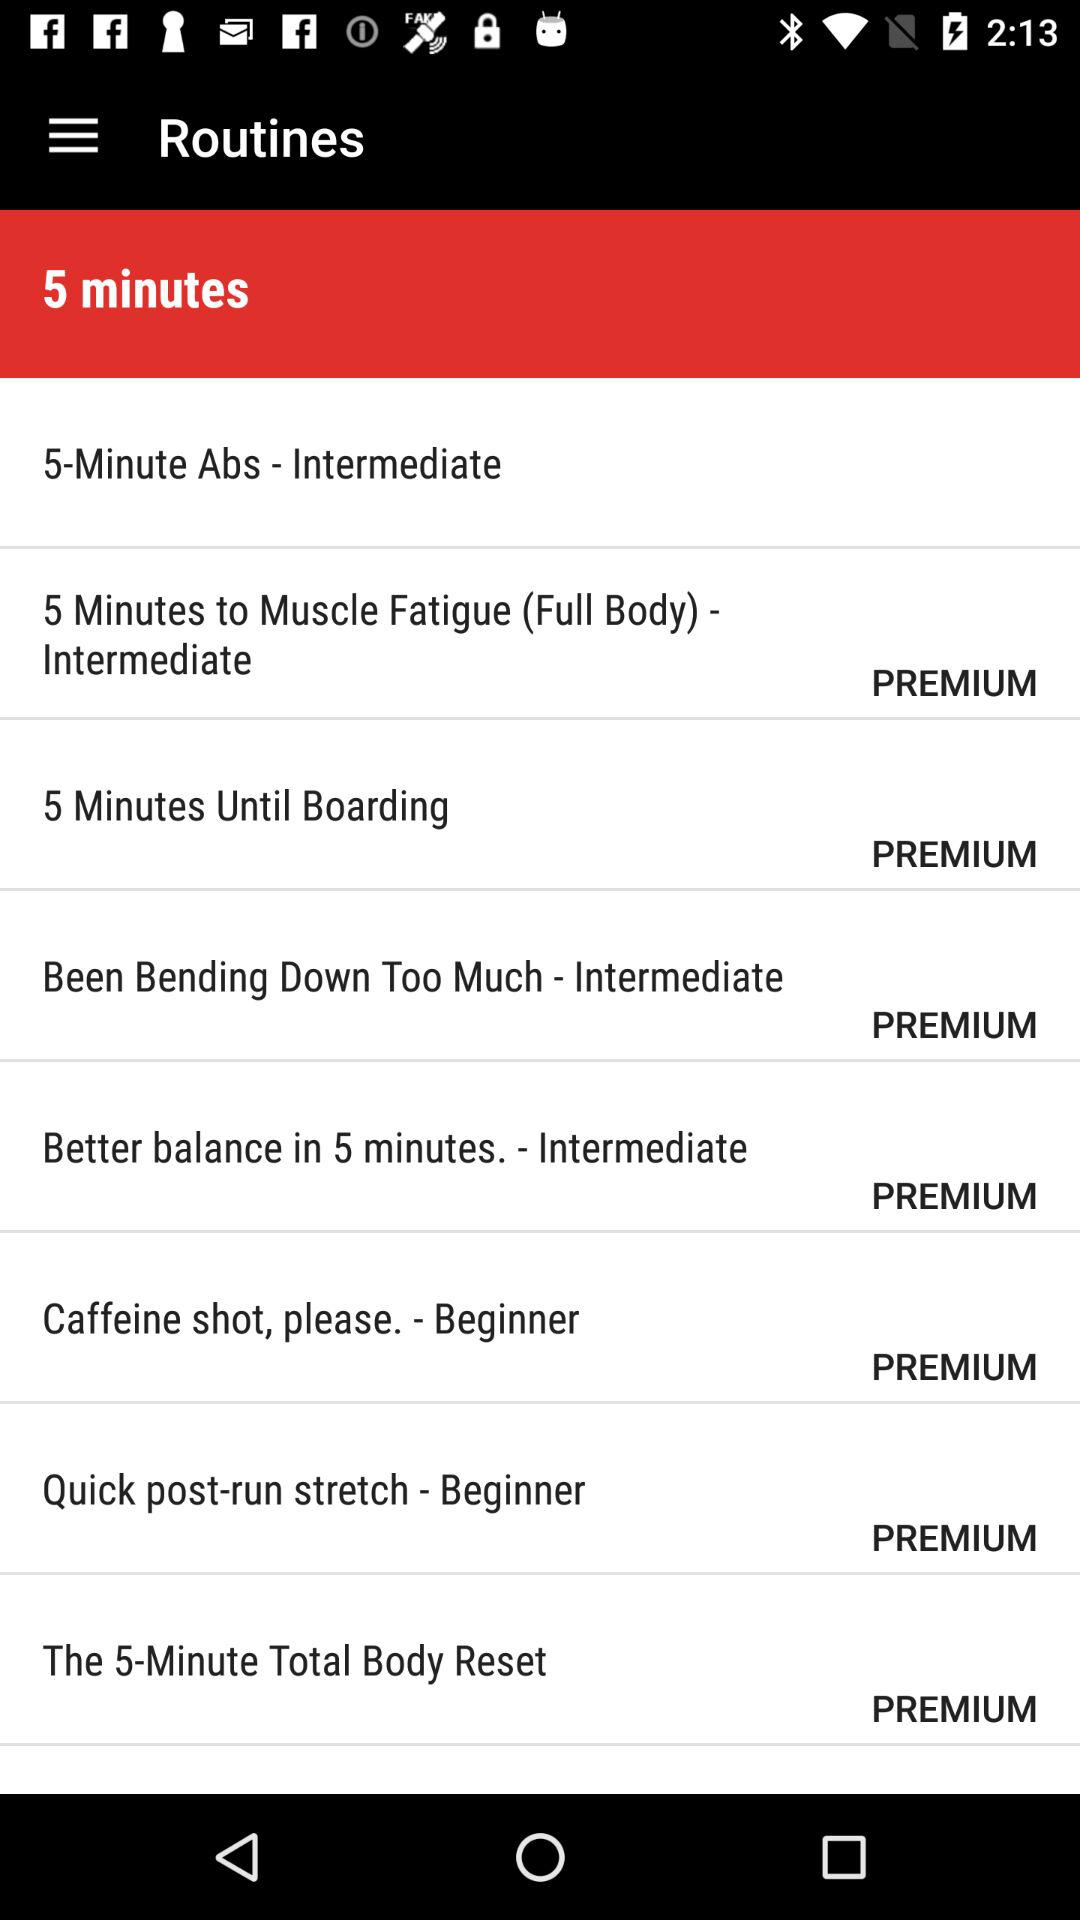Which level is mentioned for "5-Minute Abs"? The mentioned level is "Intermediate". 